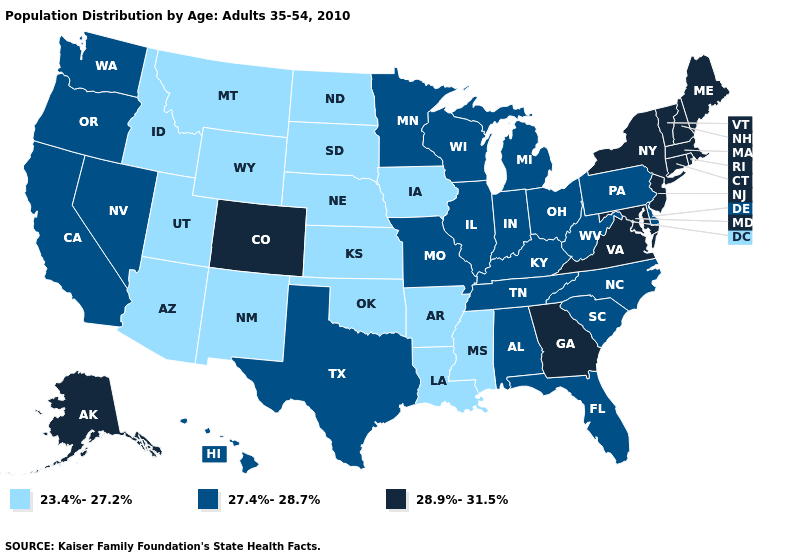Name the states that have a value in the range 23.4%-27.2%?
Give a very brief answer. Arizona, Arkansas, Idaho, Iowa, Kansas, Louisiana, Mississippi, Montana, Nebraska, New Mexico, North Dakota, Oklahoma, South Dakota, Utah, Wyoming. Name the states that have a value in the range 23.4%-27.2%?
Give a very brief answer. Arizona, Arkansas, Idaho, Iowa, Kansas, Louisiana, Mississippi, Montana, Nebraska, New Mexico, North Dakota, Oklahoma, South Dakota, Utah, Wyoming. What is the highest value in states that border Connecticut?
Concise answer only. 28.9%-31.5%. Does Pennsylvania have the same value as Rhode Island?
Give a very brief answer. No. Among the states that border Michigan , which have the lowest value?
Concise answer only. Indiana, Ohio, Wisconsin. Does Illinois have the highest value in the USA?
Be succinct. No. Is the legend a continuous bar?
Keep it brief. No. Name the states that have a value in the range 23.4%-27.2%?
Keep it brief. Arizona, Arkansas, Idaho, Iowa, Kansas, Louisiana, Mississippi, Montana, Nebraska, New Mexico, North Dakota, Oklahoma, South Dakota, Utah, Wyoming. What is the highest value in the South ?
Be succinct. 28.9%-31.5%. What is the value of Virginia?
Concise answer only. 28.9%-31.5%. Name the states that have a value in the range 23.4%-27.2%?
Concise answer only. Arizona, Arkansas, Idaho, Iowa, Kansas, Louisiana, Mississippi, Montana, Nebraska, New Mexico, North Dakota, Oklahoma, South Dakota, Utah, Wyoming. Name the states that have a value in the range 28.9%-31.5%?
Concise answer only. Alaska, Colorado, Connecticut, Georgia, Maine, Maryland, Massachusetts, New Hampshire, New Jersey, New York, Rhode Island, Vermont, Virginia. What is the value of California?
Keep it brief. 27.4%-28.7%. What is the highest value in states that border Colorado?
Quick response, please. 23.4%-27.2%. 